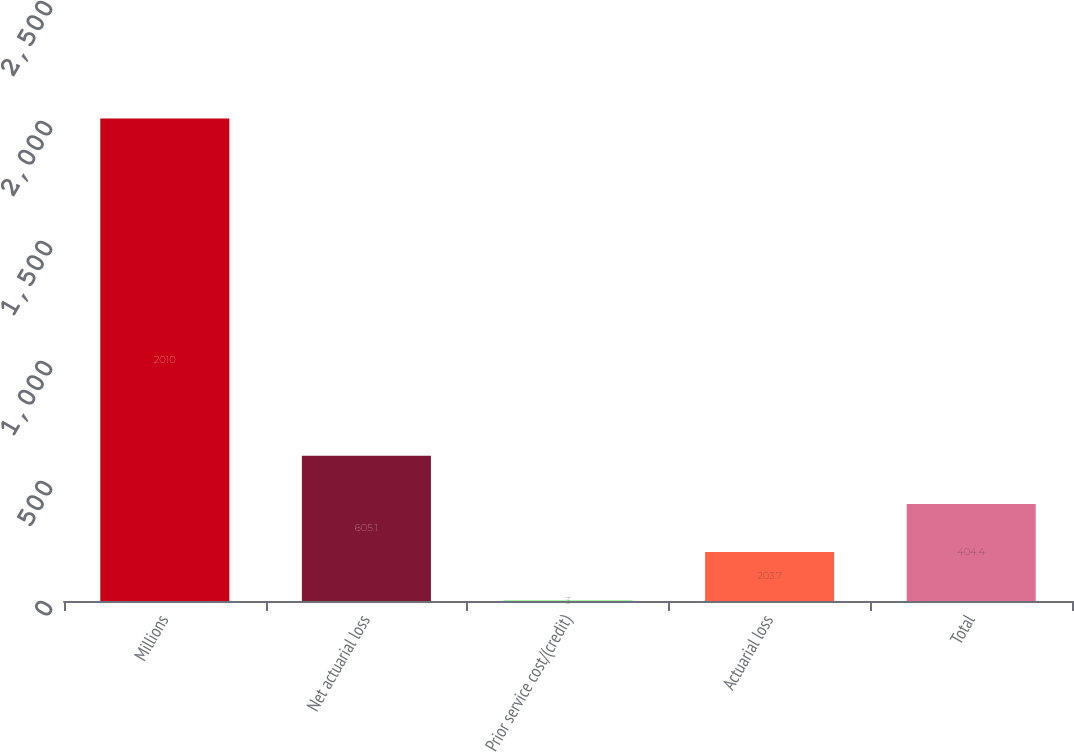Convert chart to OTSL. <chart><loc_0><loc_0><loc_500><loc_500><bar_chart><fcel>Millions<fcel>Net actuarial loss<fcel>Prior service cost/(credit)<fcel>Actuarial loss<fcel>Total<nl><fcel>2010<fcel>605.1<fcel>3<fcel>203.7<fcel>404.4<nl></chart> 